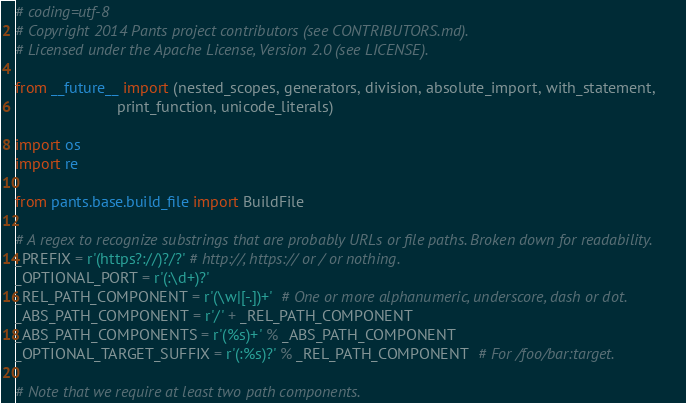<code> <loc_0><loc_0><loc_500><loc_500><_Python_># coding=utf-8
# Copyright 2014 Pants project contributors (see CONTRIBUTORS.md).
# Licensed under the Apache License, Version 2.0 (see LICENSE).

from __future__ import (nested_scopes, generators, division, absolute_import, with_statement,
                        print_function, unicode_literals)

import os
import re

from pants.base.build_file import BuildFile

# A regex to recognize substrings that are probably URLs or file paths. Broken down for readability.
_PREFIX = r'(https?://)?/?' # http://, https:// or / or nothing.
_OPTIONAL_PORT = r'(:\d+)?'
_REL_PATH_COMPONENT = r'(\w|[-.])+'  # One or more alphanumeric, underscore, dash or dot.
_ABS_PATH_COMPONENT = r'/' + _REL_PATH_COMPONENT
_ABS_PATH_COMPONENTS = r'(%s)+' % _ABS_PATH_COMPONENT
_OPTIONAL_TARGET_SUFFIX = r'(:%s)?' % _REL_PATH_COMPONENT  # For /foo/bar:target.

# Note that we require at least two path components.</code> 